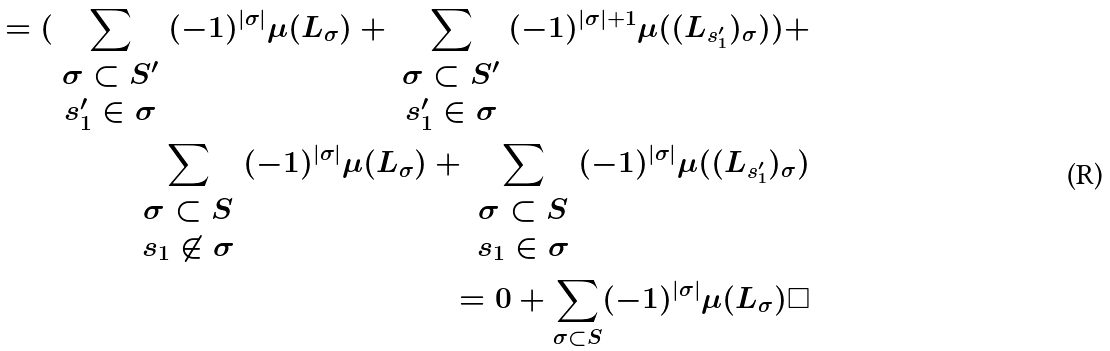<formula> <loc_0><loc_0><loc_500><loc_500>= ( \sum _ { \begin{array} { c } \sigma \subset S ^ { \prime } \\ s _ { 1 } ^ { \prime } \in \sigma \end{array} } ( - 1 ) ^ { | \sigma | } \mu ( L _ { \sigma } ) + \sum _ { \begin{array} { c } \sigma \subset S ^ { \prime } \\ s _ { 1 } ^ { \prime } \in \sigma \end{array} } ( - 1 ) ^ { | \sigma | + 1 } \mu ( ( L _ { s _ { 1 } ^ { \prime } } ) _ { \sigma } ) ) + \\ \sum _ { \begin{array} { c } \sigma \subset S \\ s _ { 1 } \not \in \sigma \end{array} } ( - 1 ) ^ { | \sigma | } \mu ( L _ { \sigma } ) + \sum _ { \begin{array} { c } \sigma \subset S \\ s _ { 1 } \in \sigma \end{array} } ( - 1 ) ^ { | \sigma | } \mu ( ( L _ { s _ { 1 } ^ { \prime } } ) _ { \sigma } ) \\ = 0 + \sum _ { \sigma \subset S } ( - 1 ) ^ { | \sigma | } \mu ( L _ { \sigma } ) \Box</formula> 